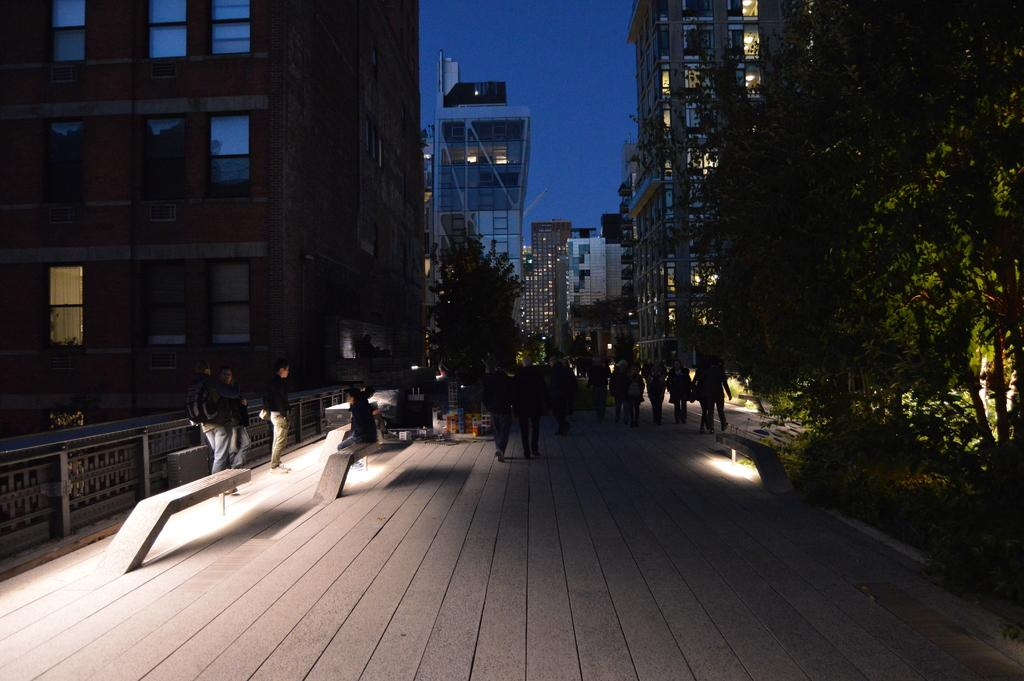What type of structures can be seen in the image? There are buildings in the image. What are the people in the image doing? There are people walking in the image. What type of vegetation is present in the image? There are trees in the image. What is visible at the top of the image? The sky is visible at the top of the image. What type of scene is the deer involved in within the image? There is no deer present in the image, so it is not possible to answer that question. 